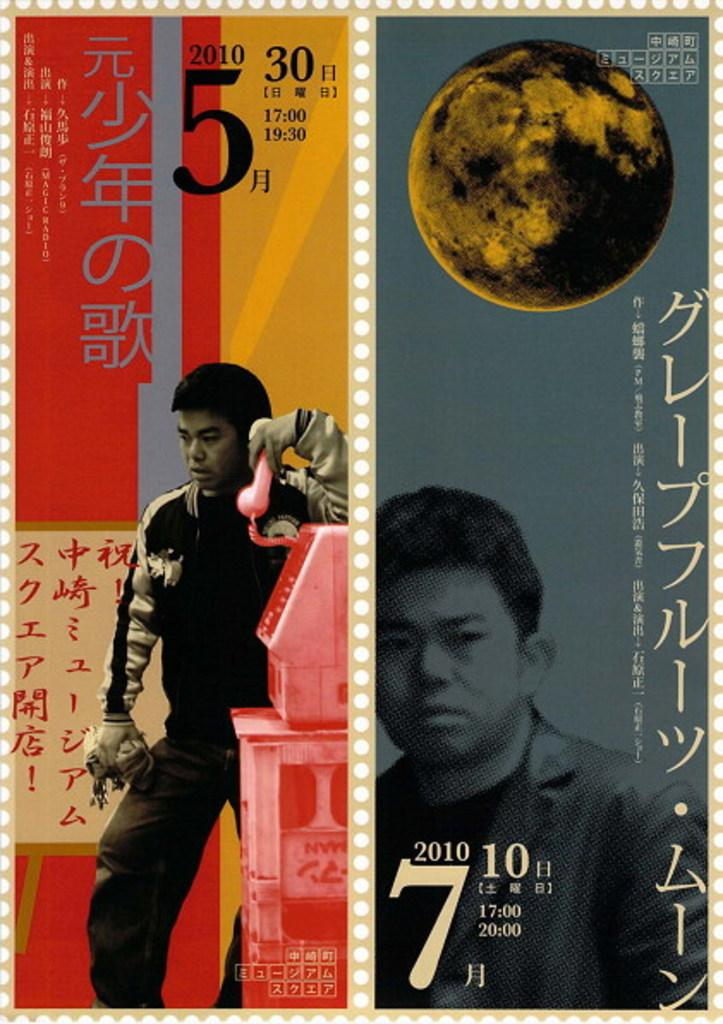<image>
Summarize the visual content of the image. A stamp featuring Asian writing and a young man pictured. 